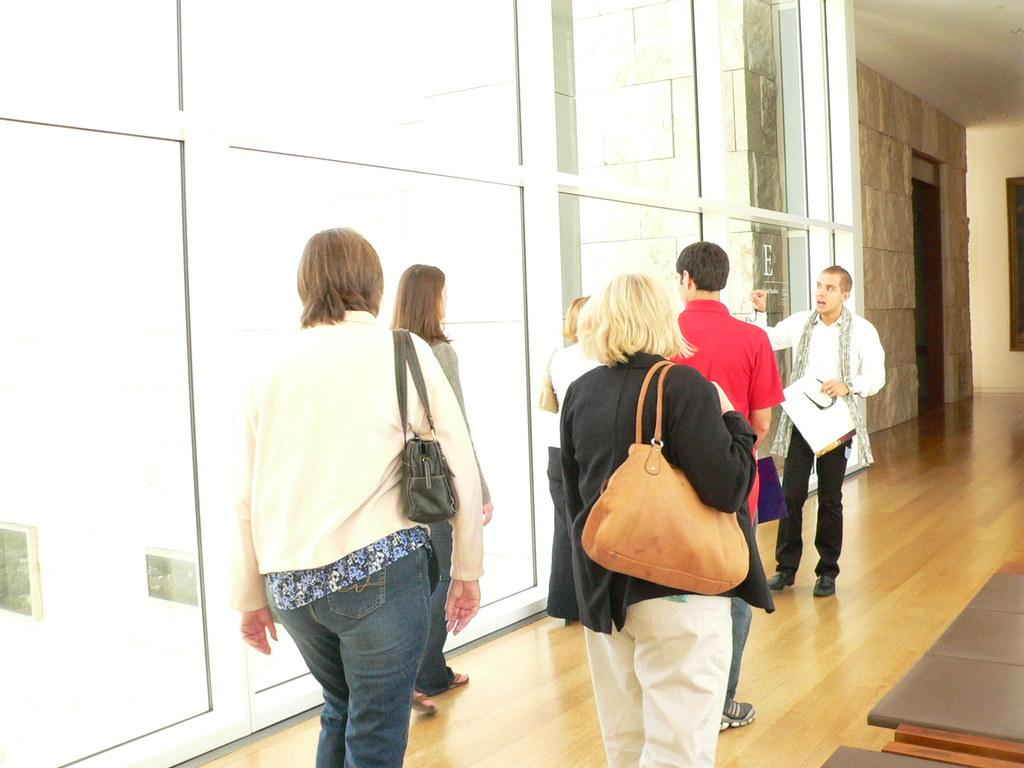How many people are in the image? There are multiple people in the image. Can you describe the gender of the people in the image? Two of the people are men, and the rest are women. What is the surface beneath the people in the image? There is a floor visible in the image. What might some of the women be carrying in the image? Some women are carrying handbags. What position does the eggnog hold in the image? There is no eggnog present in the image. Can you describe the shape of the circle in the image? There is no circle present in the image. 